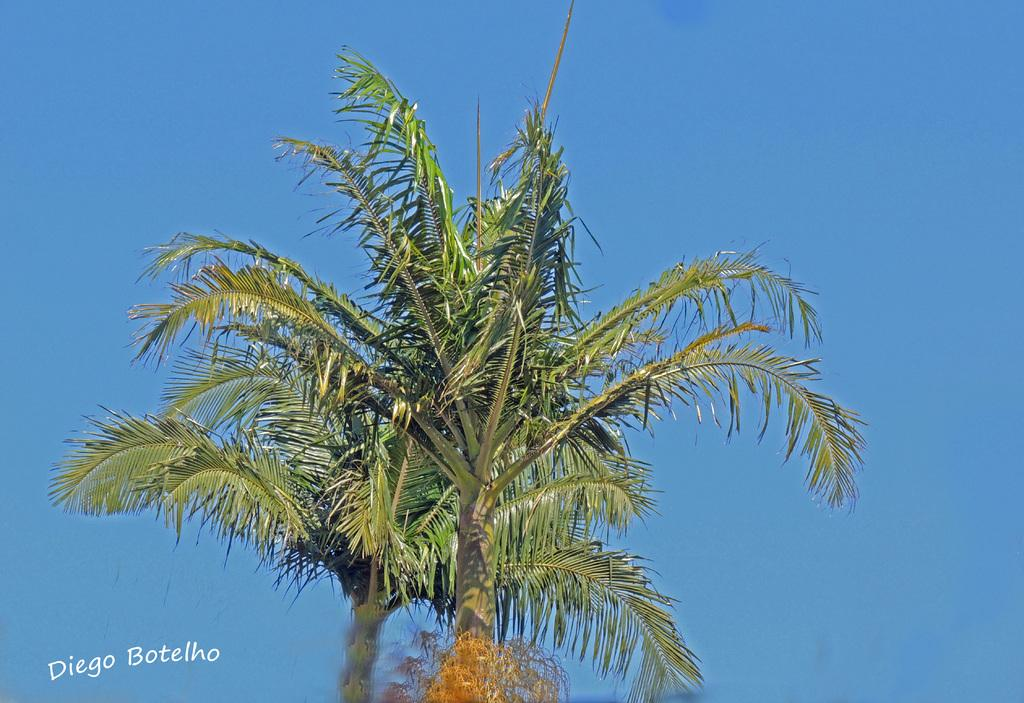What type of tree is in the image? There is a coconut tree in the image. What can be seen in the background of the image? The sky is visible in the background of the image. Where is the text located in the image? The text is at the bottom left side of the image. How many giants are visible in the image? There are no giants present in the image. What type of action is taking place in the image? There is no specific action taking place in the image; it primarily features a coconut tree and the sky in the background. 